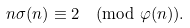<formula> <loc_0><loc_0><loc_500><loc_500>n \sigma ( n ) \equiv 2 \pmod { \varphi ( n ) } .</formula> 